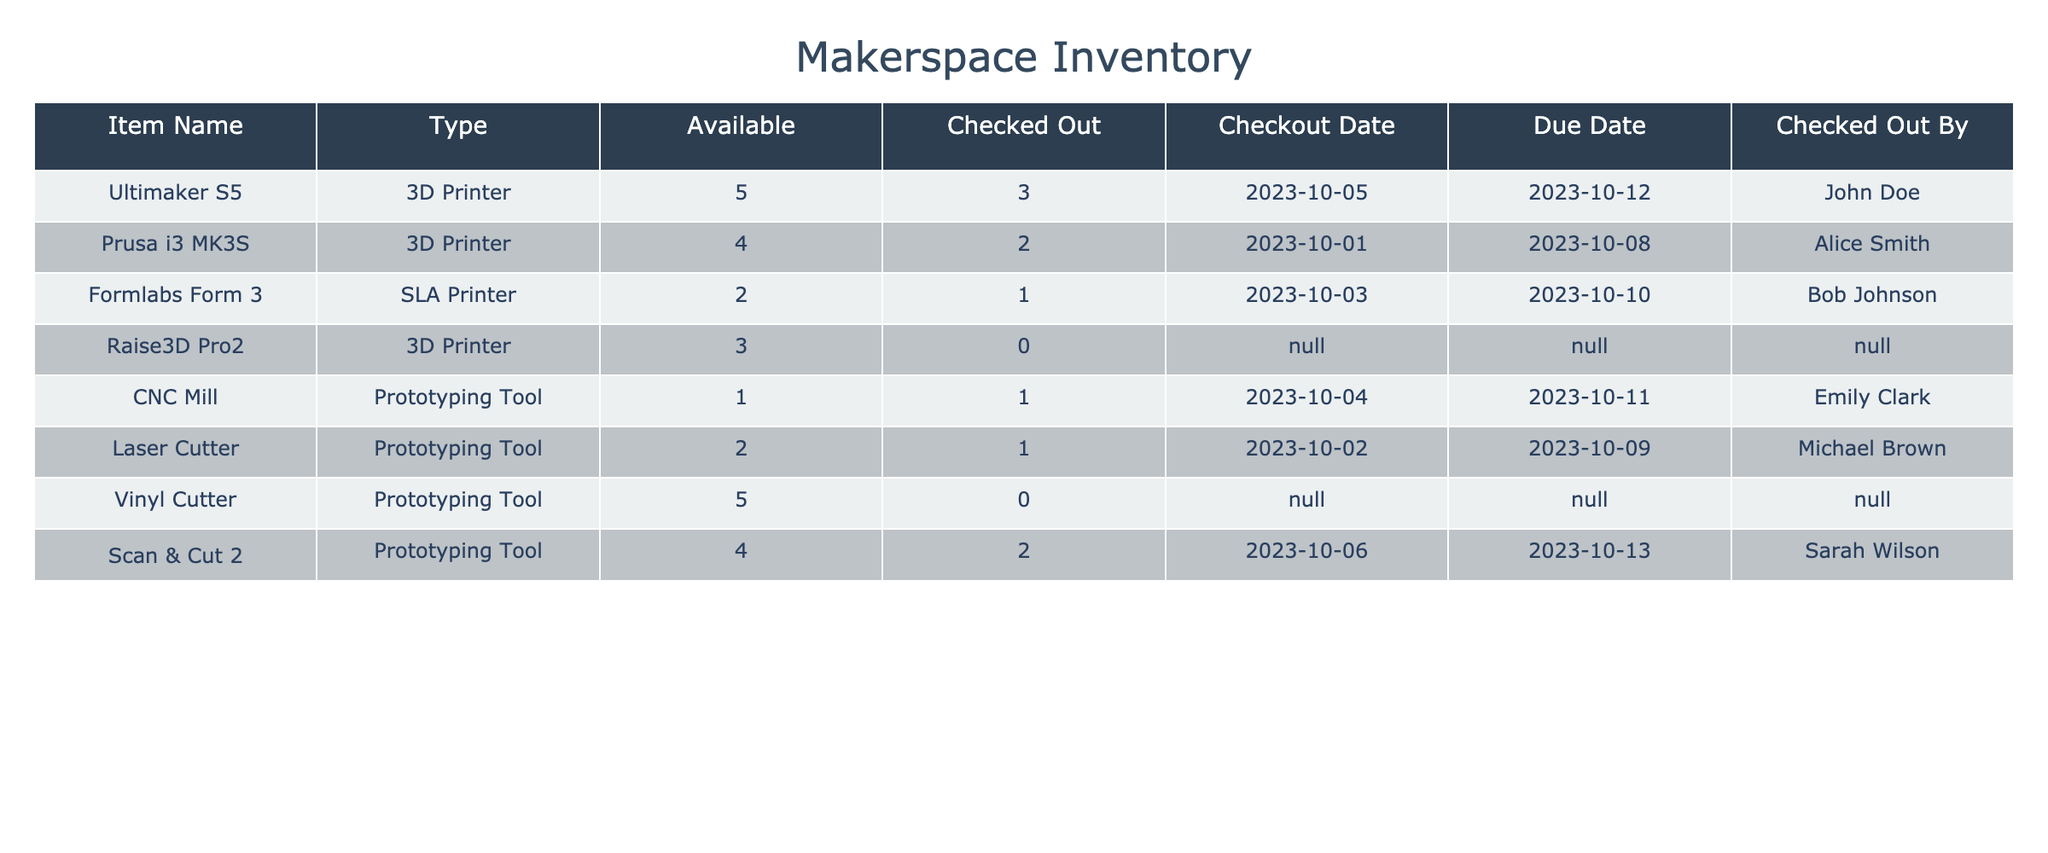What is the total number of 3D printers available in the makerspace? From the table, the available quantities for the 3D printers are: Ultimaker S5 (5), Prusa i3 MK3S (4), Raise3D Pro2 (3). To find the total available, we sum these values: 5 + 4 + 3 = 12.
Answer: 12 Which prototyping tool has the earliest due date? The due dates for the prototyping tools are: CNC Mill (2023-10-11), Laser Cutter (2023-10-09), and Vinyl Cutter has no checkouts and thus no date. The earliest due date among those listed is for the Laser Cutter.
Answer: Laser Cutter Is any item currently checked out by 'John Doe'? The table shows that 'John Doe' has checked out the Ultimaker S5, as indicated in the 'Checked Out By' column. Since he is listed there, the answer is yes.
Answer: Yes How many items are currently checked out in total? The 'Checked Out' column indicates the following: 3 (Ultimaker S5) + 2 (Prusa i3 MK3S) + 1 (Formlabs Form 3) + 1 (CNC Mill) + 1 (Laser Cutter) + 2 (Scan & Cut 2) = 10 total items.
Answer: 10 What is the ratio of available items to checked-out items for the Prusa i3 MK3S? The Prusa i3 MK3S has 4 available and 2 checked out. The ratio is calculated as available:checked out, which is 4:2. We can simplify this ratio to 2:1.
Answer: 2:1 Which item has the maximum number of available units? By inspecting the available column, the Ultimaker S5 has 5 available units, which is the highest compared to other items.
Answer: Ultimaker S5 Is the Scan & Cut 2 checked out by Sarah Wilson? According to the table, the Scan & Cut 2 lists Sarah Wilson in the 'Checked Out By' column, confirming she checked it out.
Answer: Yes How many prototyping tools are currently available? The available counts for the prototyping tools are: CNC Mill (1), Laser Cutter (2), and Vinyl Cutter (5). When we sum these up, we get 1 + 2 + 5 = 8.
Answer: 8 What is the total number of 3D printers checked out? The checked out counts for the 3D printers are: 3 (Ultimaker S5) + 2 (Prusa i3 MK3S) + 0 (Raise3D Pro2). Thus, the total checked out is 3 + 2 + 0 = 5.
Answer: 5 